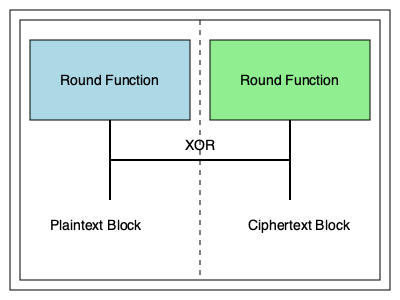In the block cipher diagram shown, what common encryption technique is illustrated by the circular path between the two round functions, and how does this technique contribute to the security of the encryption process? To answer this question, let's analyze the diagram step-by-step:

1. The diagram shows two round functions, represented by the blue and green boxes.

2. There's a line connecting the output of one round function to the input of the other, forming a circular path.

3. This circular path is characteristic of a technique called the Feistel network, named after cryptographer Horst Feistel.

4. In a Feistel network:
   a) The input block is split into two halves.
   b) One half goes through a round function while the other remains unchanged.
   c) The output of the round function is XORed with the unchanged half.
   d) The two halves are then swapped.
   e) This process is repeated for multiple rounds.

5. The XOR operation in the middle of the diagram represents the mixing of the round function output with the other half of the data.

6. The Feistel structure contributes to security in several ways:
   a) It's inherently reversible, allowing the same structure for encryption and decryption.
   b) It provides confusion and diffusion, two key principles of secure cipher design.
   c) Multiple rounds increase security by making cryptanalysis more difficult.
   d) The structure allows for the use of complex round functions without needing to invert them for decryption.

7. This design is used in many popular block ciphers, including DES and Blowfish, though not in AES which uses a different structure.

The circular path and XOR operation shown in the diagram are key identifiers of the Feistel network structure.
Answer: Feistel network 